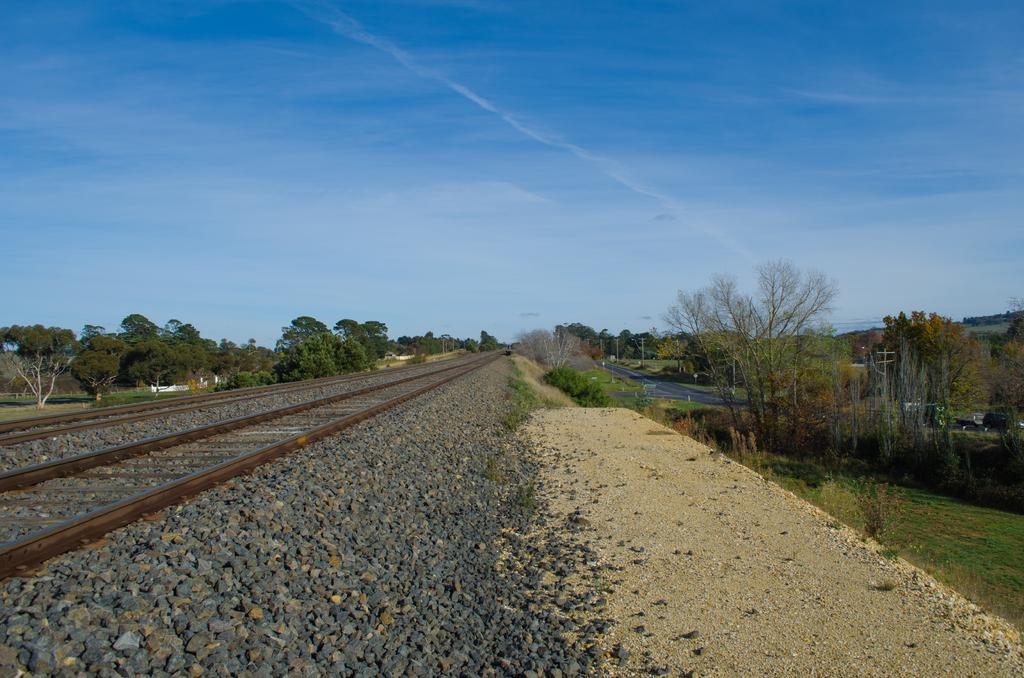What is on the ground in the image? There is a railway track on the ground in the image. What is on the railway track? There are stones on the railway track. What can be seen on both sides of the railway track? There are trees on both sides of the railway track. What word is written on the stones in the image? There is no word written on the stones in the image. What part of the human body can be seen in the image? There is no human body present in the image. 